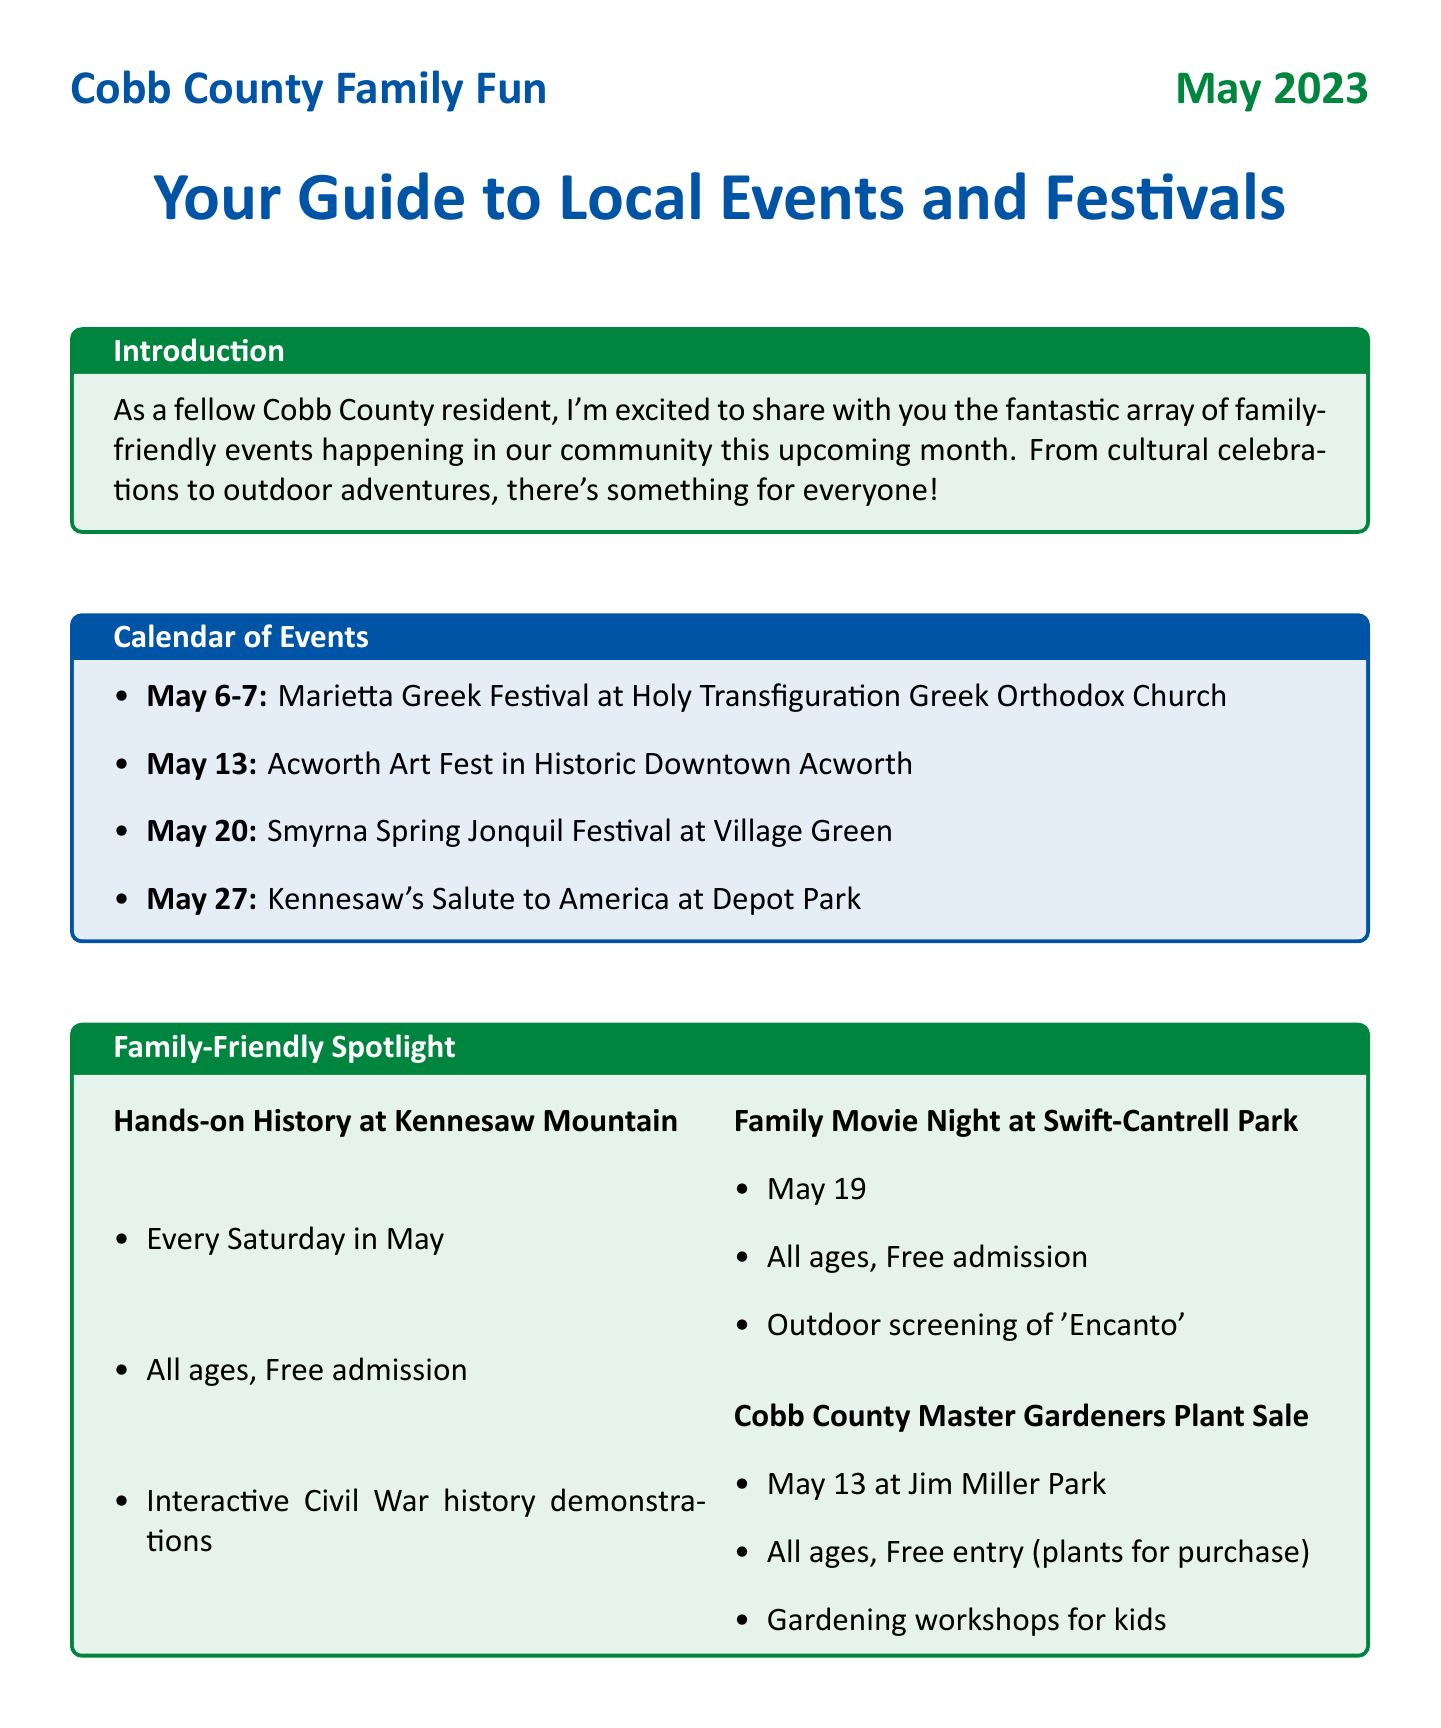What are the dates for the Marietta Greek Festival? The dates for the Marietta Greek Festival are mentioned in the document as May 6-7.
Answer: May 6-7 What is the location of the Acworth Art Fest? The document states that the Acworth Art Fest takes place in Historic Downtown Acworth.
Answer: Historic Downtown Acworth What is the age group for the STEAM Saturday at Cobb County Public Library? The document specifies that the STEAM Saturday activities are for ages 5-12 years.
Answer: 5-12 years How much does the Cobb County Farm Tour cost per person? The document lists the admission cost for the Cobb County Farm Tour as $5 per person.
Answer: $5 What type of event is Kennesaw's Salute to America? The document describes Kennesaw's Salute to America as a patriotic celebration.
Answer: Patriotic celebration On which day is the Family Movie Night at Swift-Cantrell Park? The document indicates that the Family Movie Night is on May 19.
Answer: May 19 How many farms will be visited during the Cobb County Farm Tour? The document mentions three farms: Mabry Farm, Hyde Farm, and Still Family Farm.
Answer: Three What kind of activities will kids do at the Hands-on History at Kennesaw Mountain? The document states that kids will experience Civil War history through interactive demonstrations.
Answer: Interactive demonstrations What is the main focus of this newsletter? The document's introduction highlights family-friendly events and festivals in Cobb County.
Answer: Family-friendly events and festivals 